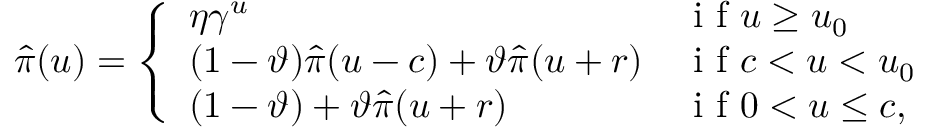Convert formula to latex. <formula><loc_0><loc_0><loc_500><loc_500>\widehat { \pi } ( u ) = \left \{ \begin{array} { l l } { \eta \gamma ^ { u } } & { i f u \geq u _ { 0 } } \\ { ( 1 - \vartheta ) \widehat { \pi } ( u - c ) + \vartheta \widehat { \pi } ( u + r ) } & { i f c < u < u _ { 0 } } \\ { ( 1 - \vartheta ) + \vartheta \widehat { \pi } ( u + r ) } & { i f 0 < u \leq c , } \end{array}</formula> 